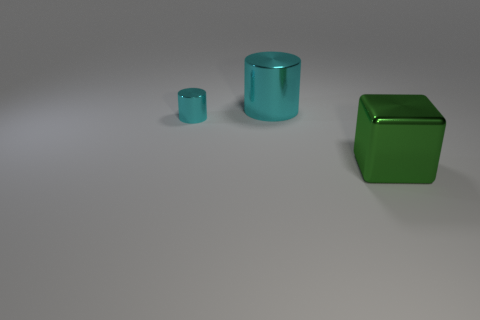Add 1 large cyan cylinders. How many objects exist? 4 Subtract all cylinders. How many objects are left? 1 Add 2 small metallic things. How many small metallic things are left? 3 Add 1 large purple rubber cylinders. How many large purple rubber cylinders exist? 1 Subtract 1 cyan cylinders. How many objects are left? 2 Subtract all tiny purple cubes. Subtract all tiny cylinders. How many objects are left? 2 